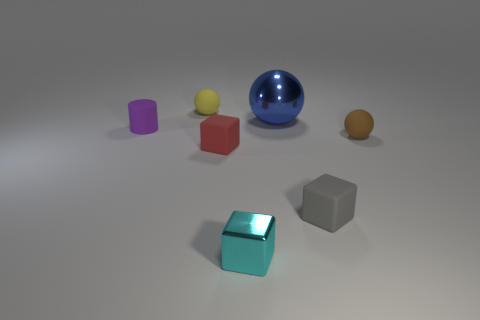Add 3 cyan blocks. How many objects exist? 10 Subtract all cylinders. How many objects are left? 6 Subtract 1 cyan cubes. How many objects are left? 6 Subtract all red cubes. Subtract all large blue objects. How many objects are left? 5 Add 1 tiny gray objects. How many tiny gray objects are left? 2 Add 6 small green matte blocks. How many small green matte blocks exist? 6 